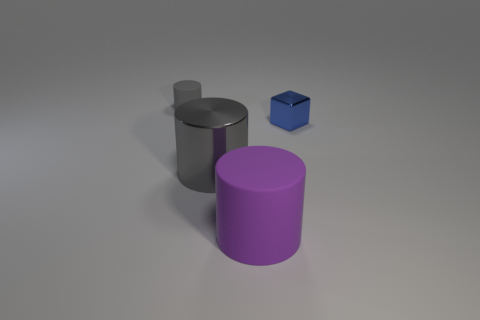There is another gray object that is the same shape as the gray shiny thing; what is its size?
Provide a short and direct response. Small. The tiny object that is the same shape as the large purple thing is what color?
Offer a terse response. Gray. There is a shiny object that is to the left of the big purple rubber cylinder; is it the same color as the tiny cylinder?
Provide a short and direct response. Yes. Is the shiny cylinder the same size as the purple thing?
Ensure brevity in your answer.  Yes. There is a gray thing that is the same material as the small blue block; what shape is it?
Make the answer very short. Cylinder. What number of other objects are there of the same shape as the blue metal thing?
Your answer should be very brief. 0. There is a large object that is right of the gray cylinder right of the matte object that is to the left of the purple cylinder; what shape is it?
Provide a short and direct response. Cylinder. What number of cylinders are either large blue shiny things or rubber things?
Offer a very short reply. 2. Are there any purple things in front of the matte cylinder that is in front of the small metallic object?
Your answer should be very brief. No. Is there any other thing that is made of the same material as the cube?
Give a very brief answer. Yes. 